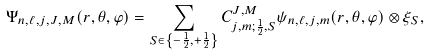Convert formula to latex. <formula><loc_0><loc_0><loc_500><loc_500>\Psi _ { n , \ell , j , J , M } ( r , \theta , \varphi ) = \sum _ { S \in \left \{ - \frac { 1 } { 2 } , + \frac { 1 } { 2 } \right \} } C _ { j , m ; \frac { 1 } { 2 } , S } ^ { J , M } \psi _ { n , \ell , j , m } ( r , \theta , \varphi ) \otimes \xi _ { S } ,</formula> 